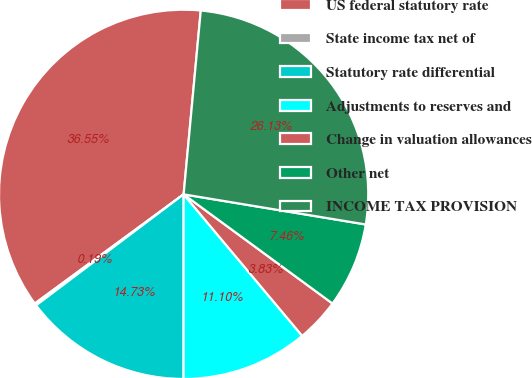Convert chart. <chart><loc_0><loc_0><loc_500><loc_500><pie_chart><fcel>US federal statutory rate<fcel>State income tax net of<fcel>Statutory rate differential<fcel>Adjustments to reserves and<fcel>Change in valuation allowances<fcel>Other net<fcel>INCOME TAX PROVISION<nl><fcel>36.55%<fcel>0.19%<fcel>14.73%<fcel>11.1%<fcel>3.83%<fcel>7.46%<fcel>26.13%<nl></chart> 